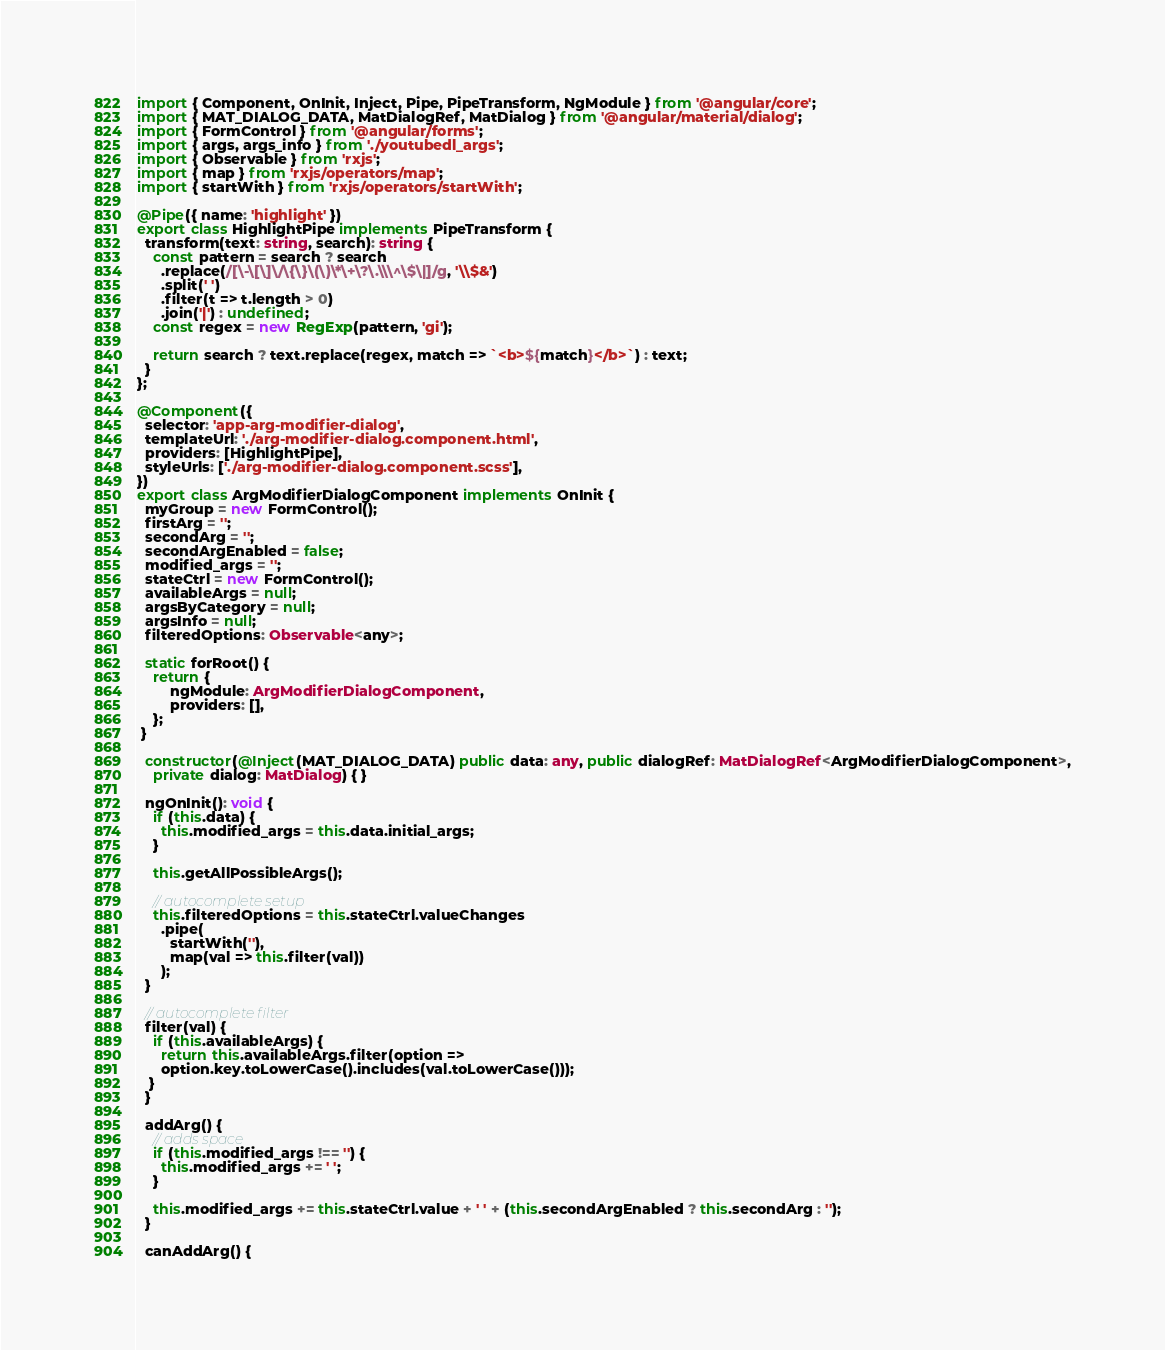<code> <loc_0><loc_0><loc_500><loc_500><_TypeScript_>import { Component, OnInit, Inject, Pipe, PipeTransform, NgModule } from '@angular/core';
import { MAT_DIALOG_DATA, MatDialogRef, MatDialog } from '@angular/material/dialog';
import { FormControl } from '@angular/forms';
import { args, args_info } from './youtubedl_args';
import { Observable } from 'rxjs';
import { map } from 'rxjs/operators/map';
import { startWith } from 'rxjs/operators/startWith';

@Pipe({ name: 'highlight' })
export class HighlightPipe implements PipeTransform {
  transform(text: string, search): string {
    const pattern = search ? search
      .replace(/[\-\[\]\/\{\}\(\)\*\+\?\.\\\^\$\|]/g, '\\$&')
      .split(' ')
      .filter(t => t.length > 0)
      .join('|') : undefined;
    const regex = new RegExp(pattern, 'gi');

    return search ? text.replace(regex, match => `<b>${match}</b>`) : text;
  }
};

@Component({
  selector: 'app-arg-modifier-dialog',
  templateUrl: './arg-modifier-dialog.component.html',
  providers: [HighlightPipe],
  styleUrls: ['./arg-modifier-dialog.component.scss'],
})
export class ArgModifierDialogComponent implements OnInit {
  myGroup = new FormControl();
  firstArg = '';
  secondArg = '';
  secondArgEnabled = false;
  modified_args = '';
  stateCtrl = new FormControl();
  availableArgs = null;
  argsByCategory = null;
  argsInfo = null;
  filteredOptions: Observable<any>;

  static forRoot() {
    return {
        ngModule: ArgModifierDialogComponent,
        providers: [],
    };
 }

  constructor(@Inject(MAT_DIALOG_DATA) public data: any, public dialogRef: MatDialogRef<ArgModifierDialogComponent>,
    private dialog: MatDialog) { }

  ngOnInit(): void {
    if (this.data) {
      this.modified_args = this.data.initial_args;
    }

    this.getAllPossibleArgs();

    // autocomplete setup
    this.filteredOptions = this.stateCtrl.valueChanges
      .pipe(
        startWith(''),
        map(val => this.filter(val))
      );
  }

  // autocomplete filter
  filter(val) {
    if (this.availableArgs) {
      return this.availableArgs.filter(option =>
      option.key.toLowerCase().includes(val.toLowerCase()));
   }
  }

  addArg() {
    // adds space
    if (this.modified_args !== '') {
      this.modified_args += ' ';
    }

    this.modified_args += this.stateCtrl.value + ' ' + (this.secondArgEnabled ? this.secondArg : '');
  }

  canAddArg() {</code> 